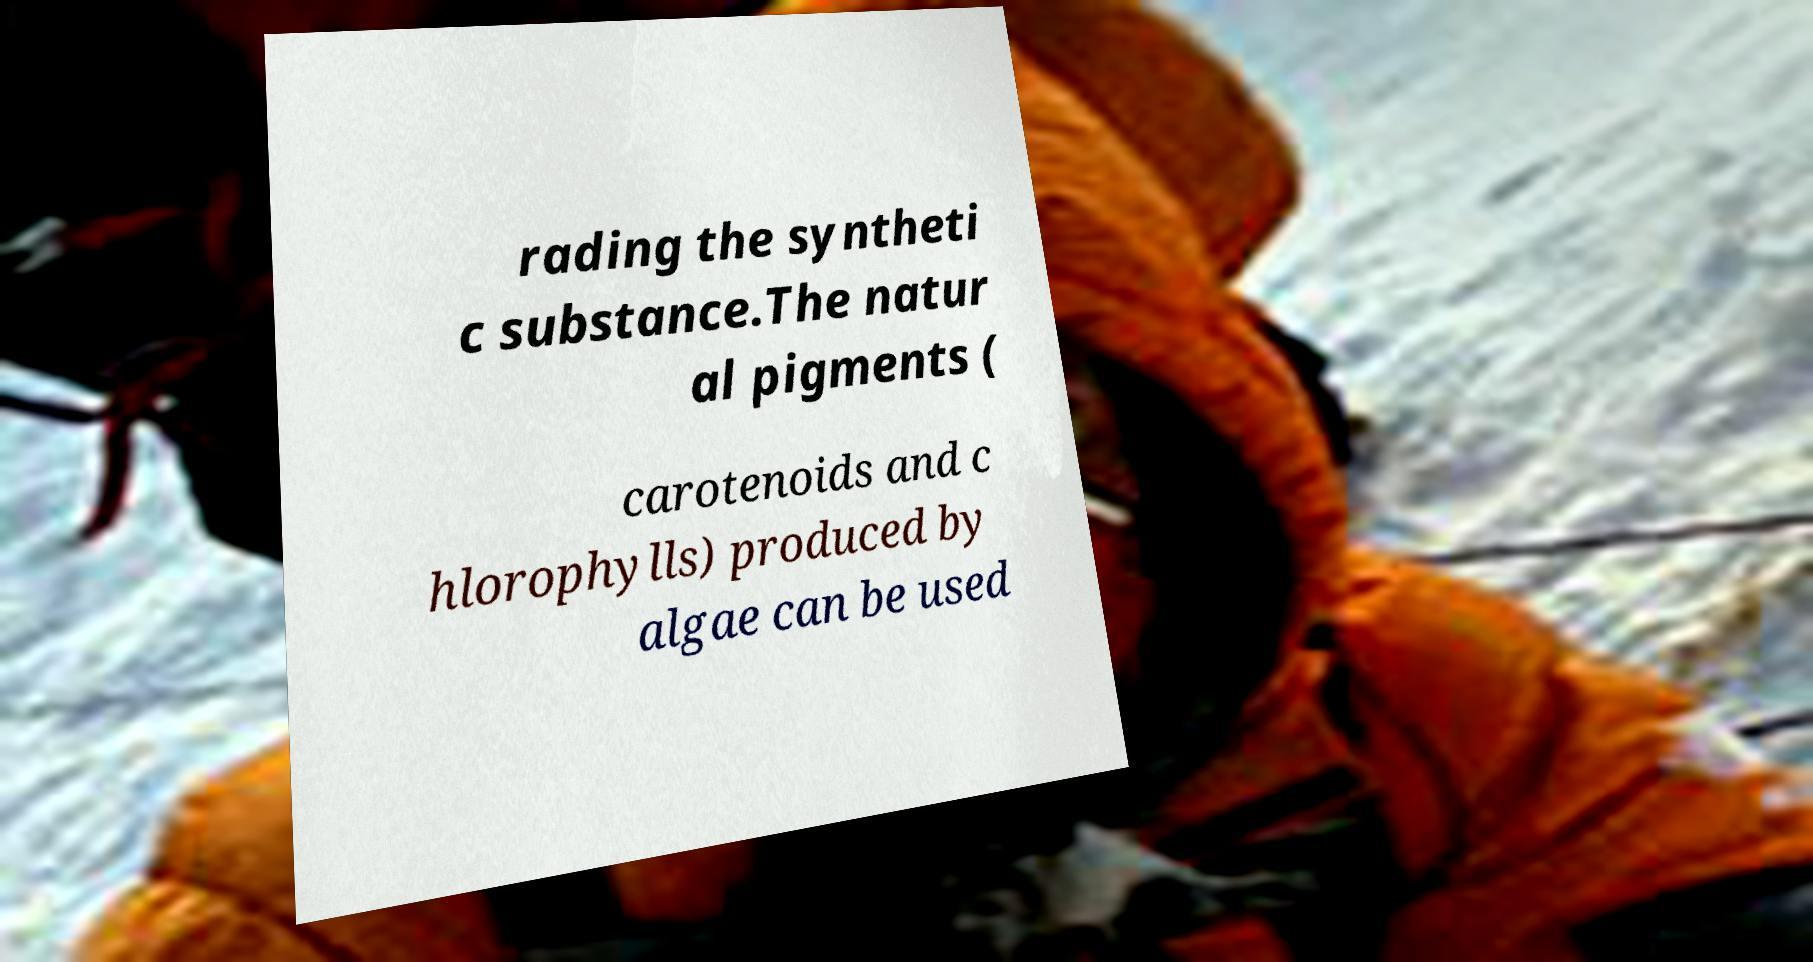What messages or text are displayed in this image? I need them in a readable, typed format. rading the syntheti c substance.The natur al pigments ( carotenoids and c hlorophylls) produced by algae can be used 